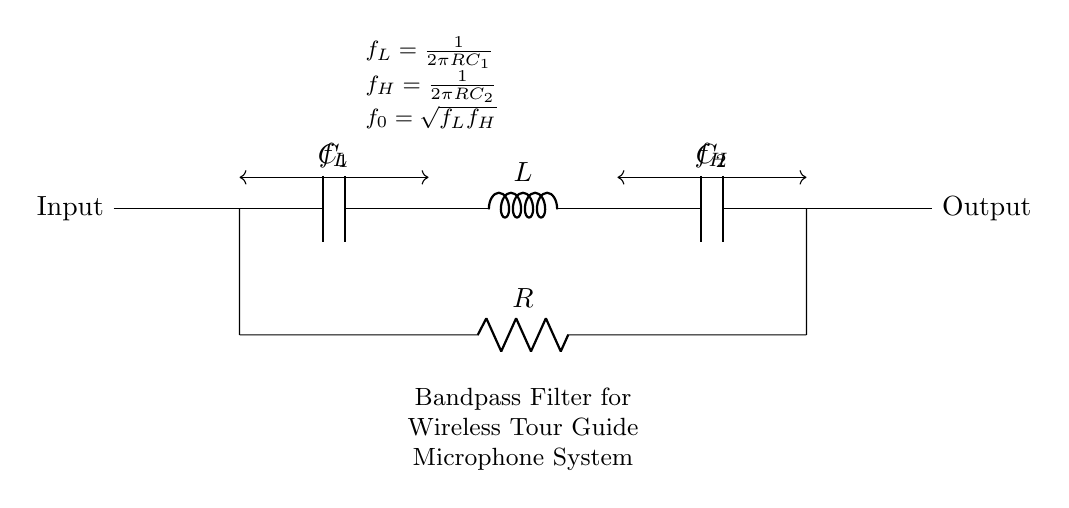What type of filter is represented in this circuit? The circuit diagram shows a bandpass filter, which allows signals within a certain frequency range to pass while attenuating frequencies outside that range. This is indicated by the labeling in the diagram.
Answer: Bandpass filter What are the component values used in this circuit? The circuit contains a capacitor labeled C1, a inductor labeled L, a capacitor labeled C2, and a resistor labeled R. The specific values are not provided in the diagram but are represented by their labels.
Answer: C1, L, C2, R What does f_L represent in this context? f_L is the lower cutoff frequency and it is calculated using the formula f_L = 1/(2πRC1). This shows the frequency at which the filter starts to allow signals to pass.
Answer: Lower cutoff frequency What does f_H represent in this configuration? f_H is the upper cutoff frequency defined as f_H = 1/(2πRC2). It indicates the frequency at which signals above this point are attenuated by the filter.
Answer: Upper cutoff frequency What is the formula for f_0 in this circuit? The circuit shows that f_0, the center frequency, is calculated as f_0 = sqrt(f_L f_H). This provides the frequency at which the filter has its maximum response.
Answer: sqrt(f_L f_H) How does the resistor influence the cutoff frequencies? The resistor R directly influences both cutoff frequencies as a component in the formulas for f_L and f_H. Increasing R will lower both f_L and f_H, thereby affecting the entire passband.
Answer: Resistor R What are the main functions of C1 and C2 in this filter? Capacitor C1 helps define the lower cutoff frequency and C2 helps define the upper cutoff frequency in the bandpass filter, influencing which frequencies will pass through.
Answer: Define cutoff frequencies 